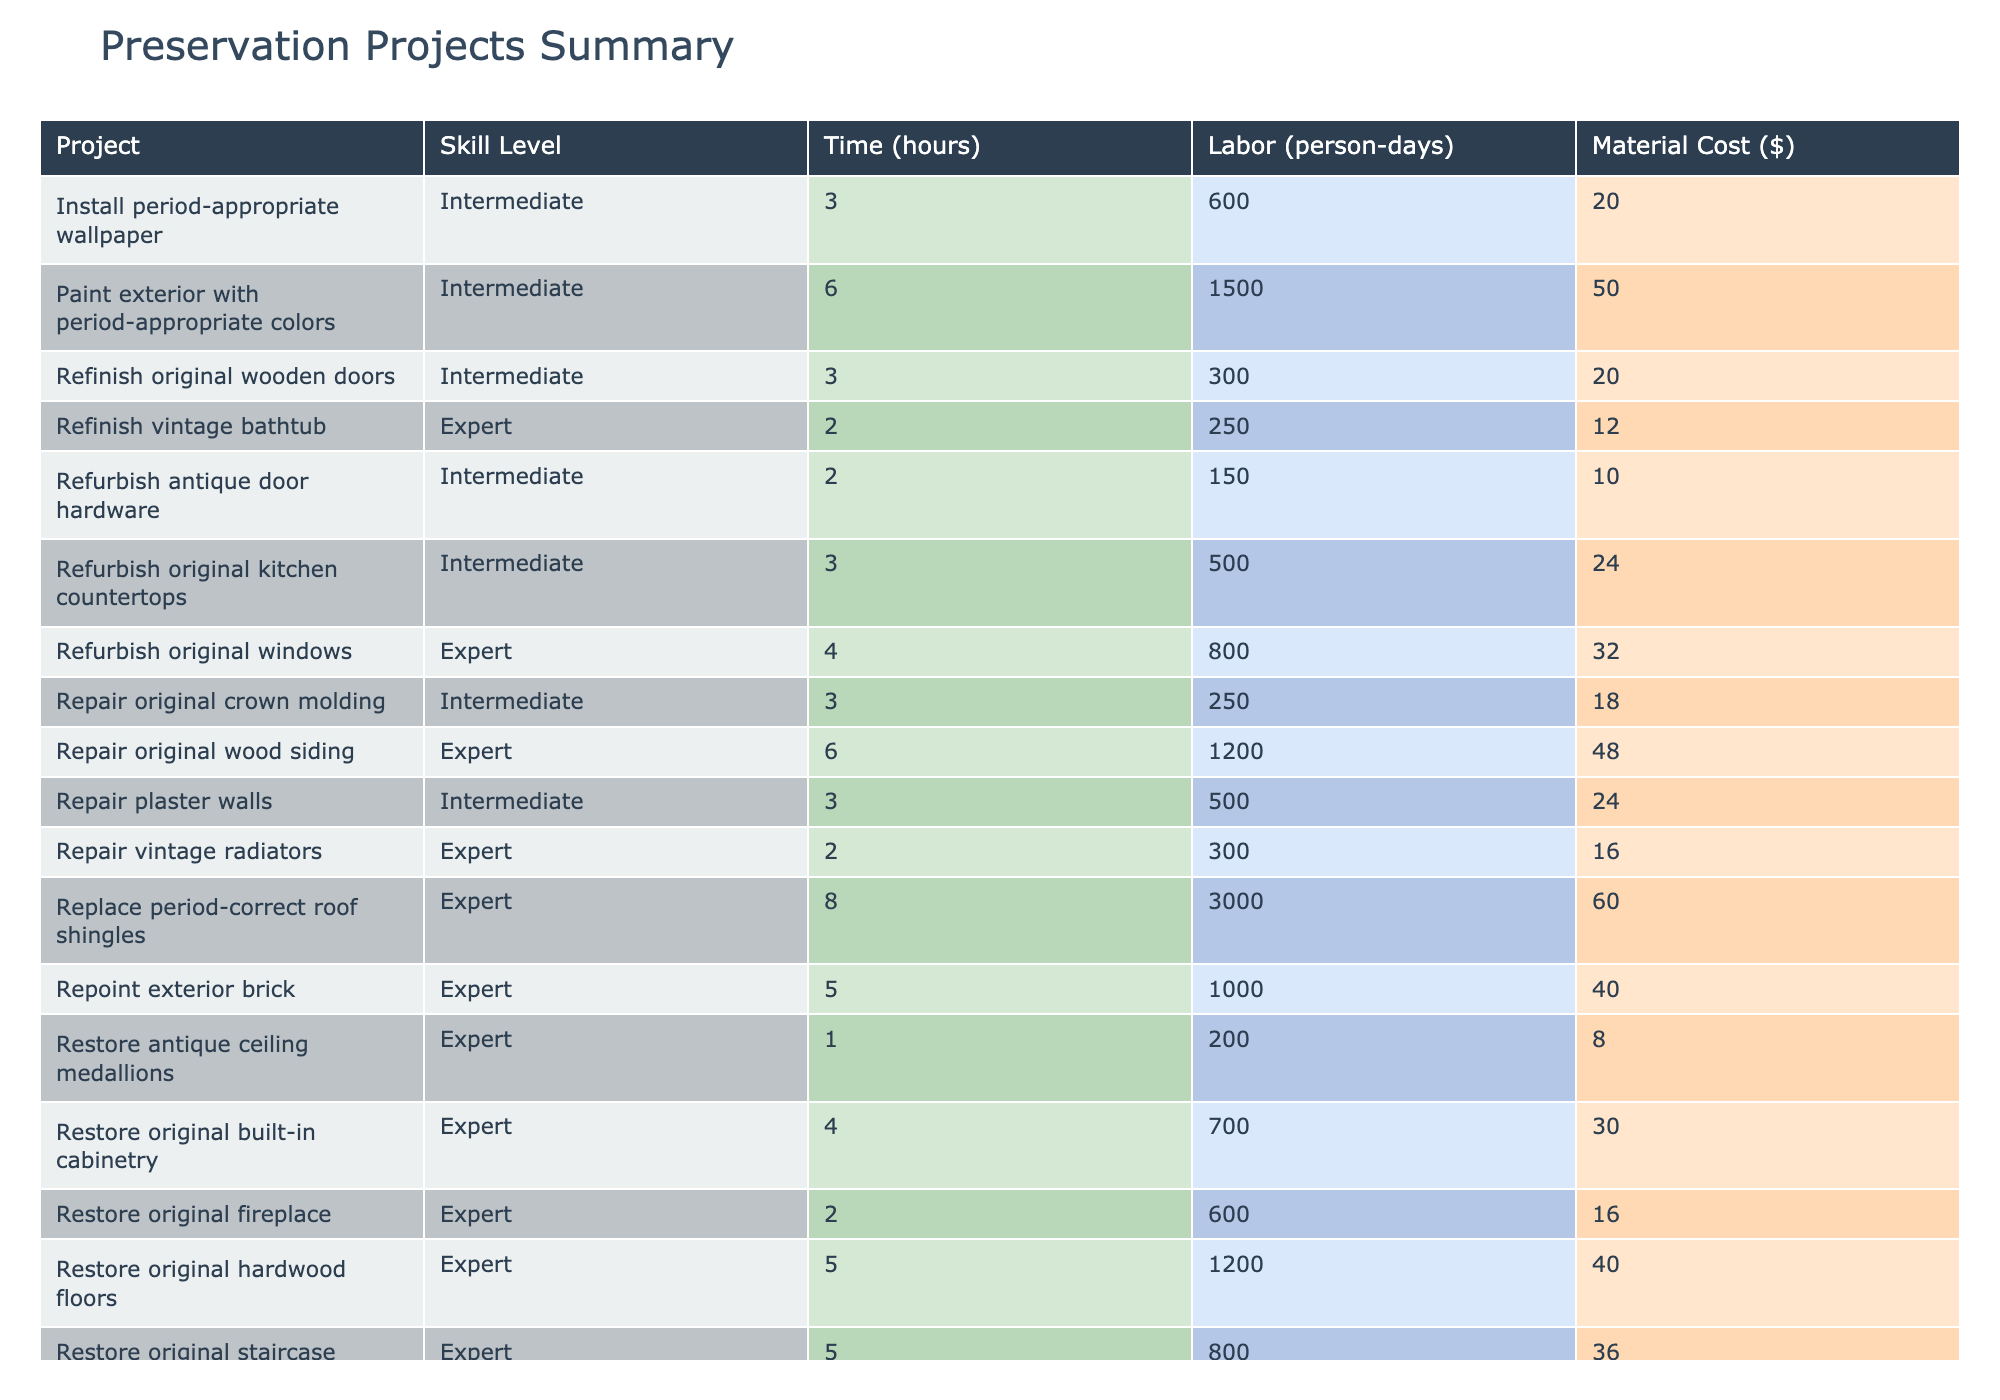What is the skill level required for restoring original hardwood floors? The table lists the skill levels for each project. For "Restore original hardwood floors," it shows "Expert" as the skill level.
Answer: Expert Which project requires the highest material cost? By looking at the "Material Cost ($)" column, the highest value is for "Replace period-correct roof shingles" at $3000.
Answer: $3000 How many total labor days are needed for all expert-level projects combined? The projects with "Expert" skill level include "Restore original hardwood floors" (5), "Refurbish original windows" (4), "Restore original fireplace" (2), "Restore original built-in cabinetry" (4), "Repoint exterior brick" (5), "Restore original staircase" (5), "Repair original wood siding" (6), "Restore antique ceiling medallions" (1), totaling 32 person-days (5 + 4 + 2 + 4 + 5 + 5 + 6 + 1 = 32).
Answer: 32 Is it true that the "Paint exterior with period-appropriate colors" project requires more time than the "Restore original fireplace"? Comparing the "Time (hours)" for both, "Paint exterior with period-appropriate colors" is 50 hours while "Restore original fireplace" is 16 hours, therefore it is true.
Answer: Yes What is the average time required for all projects in the table? First, sum the time for each project: 40 + 24 + 32 + 50 + 16 + 60 + 20 + 12 + 18 + 30 + 40 + 10 + 24 + 16 + 20 + 36 + 12 + 48 + 8 + 24 = 484 hours. There are 20 projects, so the average time is 484/20 = 24.2 hours.
Answer: 24.2 